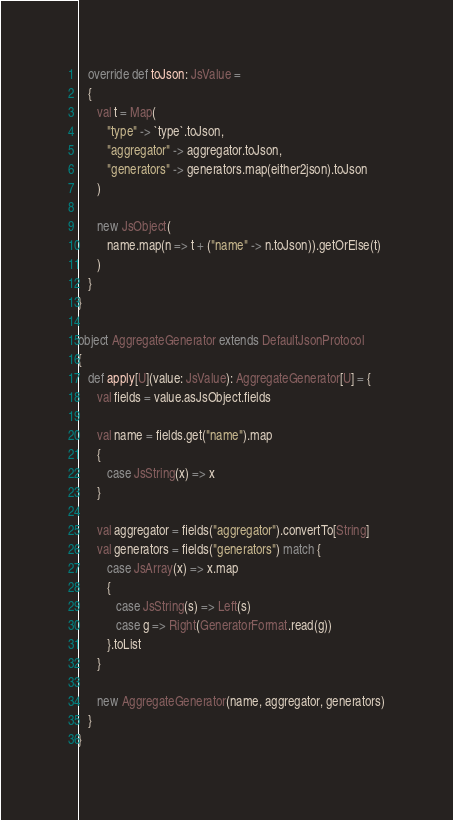Convert code to text. <code><loc_0><loc_0><loc_500><loc_500><_Scala_>
   override def toJson: JsValue =
   {
      val t = Map(
         "type" -> `type`.toJson,
         "aggregator" -> aggregator.toJson,
         "generators" -> generators.map(either2json).toJson
      )

      new JsObject(
         name.map(n => t + ("name" -> n.toJson)).getOrElse(t)
      )
   }
}

object AggregateGenerator extends DefaultJsonProtocol
{
   def apply[U](value: JsValue): AggregateGenerator[U] = {
      val fields = value.asJsObject.fields

      val name = fields.get("name").map
      {
         case JsString(x) => x
      }

      val aggregator = fields("aggregator").convertTo[String]
      val generators = fields("generators") match {
         case JsArray(x) => x.map
         {
            case JsString(s) => Left(s)
            case g => Right(GeneratorFormat.read(g))
         }.toList
      }

      new AggregateGenerator(name, aggregator, generators)
   }
}
</code> 